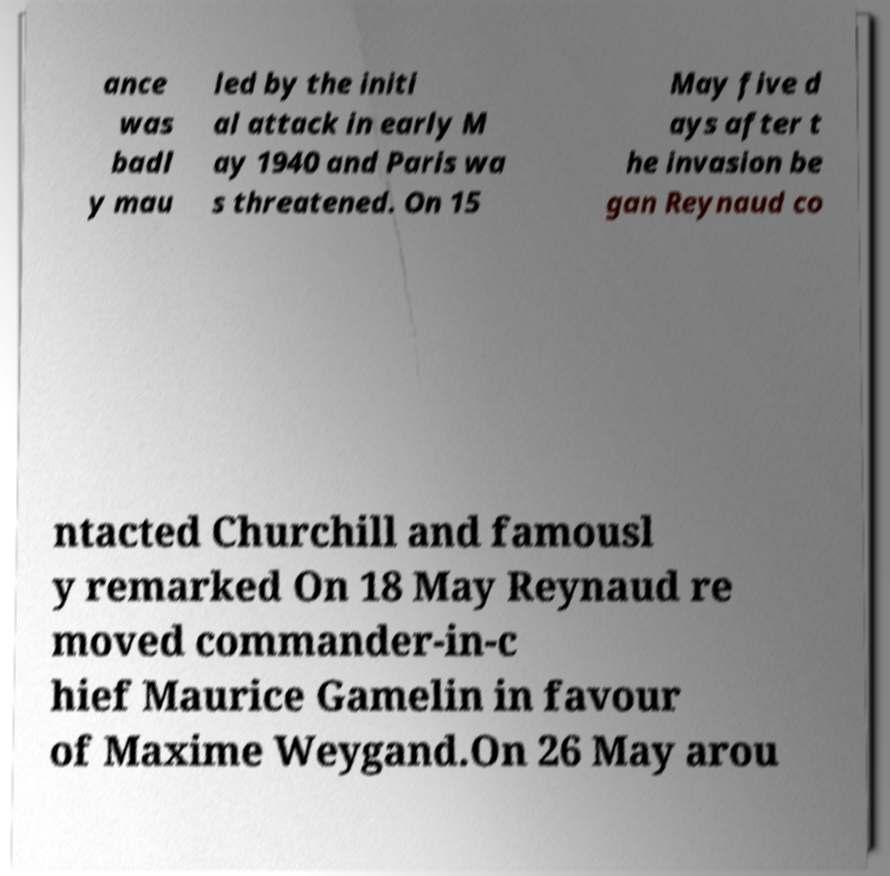Can you accurately transcribe the text from the provided image for me? ance was badl y mau led by the initi al attack in early M ay 1940 and Paris wa s threatened. On 15 May five d ays after t he invasion be gan Reynaud co ntacted Churchill and famousl y remarked On 18 May Reynaud re moved commander-in-c hief Maurice Gamelin in favour of Maxime Weygand.On 26 May arou 